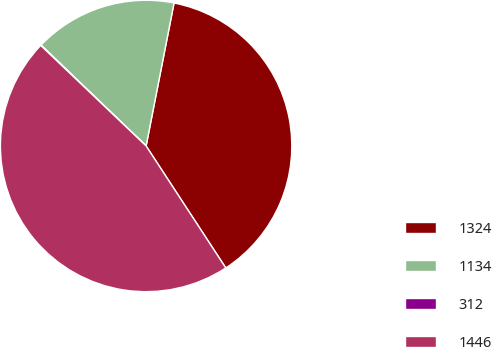Convert chart. <chart><loc_0><loc_0><loc_500><loc_500><pie_chart><fcel>1324<fcel>1134<fcel>312<fcel>1446<nl><fcel>37.72%<fcel>15.89%<fcel>0.06%<fcel>46.33%<nl></chart> 